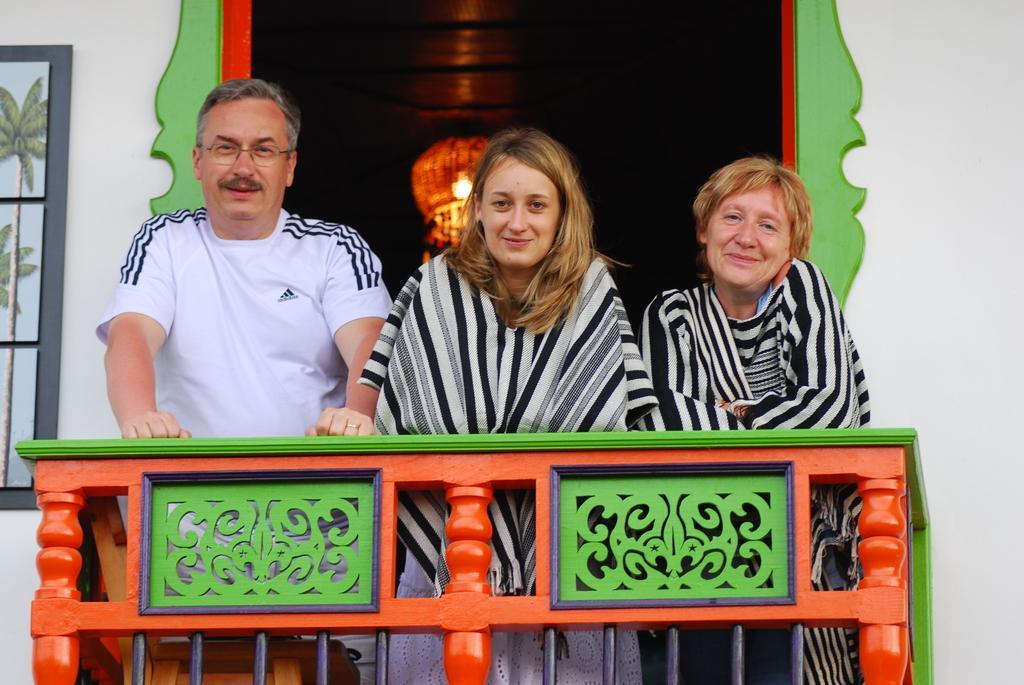In one or two sentences, can you explain what this image depicts? There is a person in white color t-shirt, standing on the floor near wooden chair, fencing and other two women who are standing and smiling. In the background, there is a light which is attached to the roof, there are tiles attached to the white wall of the building. 